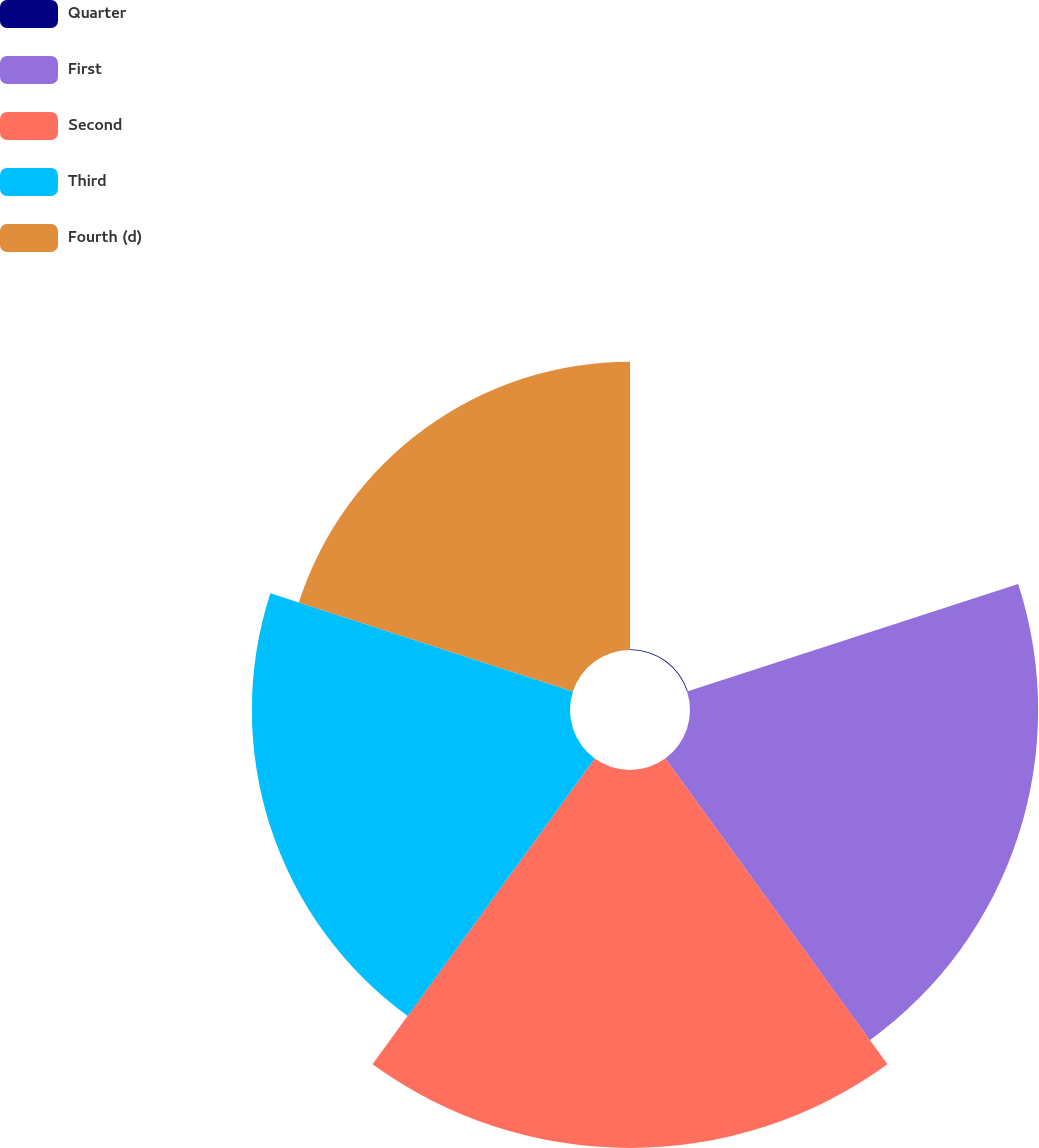Convert chart. <chart><loc_0><loc_0><loc_500><loc_500><pie_chart><fcel>Quarter<fcel>First<fcel>Second<fcel>Third<fcel>Fourth (d)<nl><fcel>0.06%<fcel>26.11%<fcel>28.35%<fcel>23.86%<fcel>21.62%<nl></chart> 